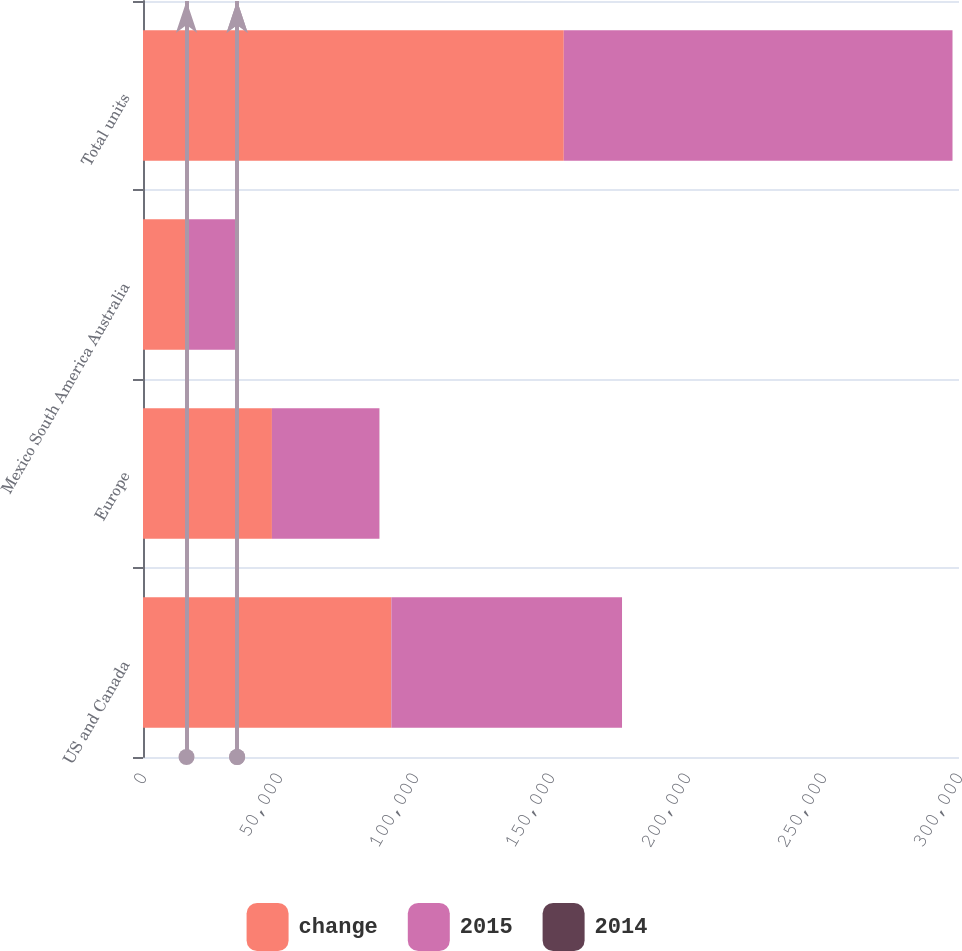<chart> <loc_0><loc_0><loc_500><loc_500><stacked_bar_chart><ecel><fcel>US and Canada<fcel>Europe<fcel>Mexico South America Australia<fcel>Total units<nl><fcel>change<fcel>91300<fcel>47400<fcel>16000<fcel>154700<nl><fcel>2015<fcel>84800<fcel>39500<fcel>18600<fcel>142900<nl><fcel>2014<fcel>8<fcel>20<fcel>14<fcel>8<nl></chart> 